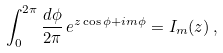Convert formula to latex. <formula><loc_0><loc_0><loc_500><loc_500>\int _ { 0 } ^ { 2 \pi } \frac { d \phi } { 2 \pi } \, e ^ { z \cos \phi + i m \phi } = I _ { m } ( z ) \, ,</formula> 